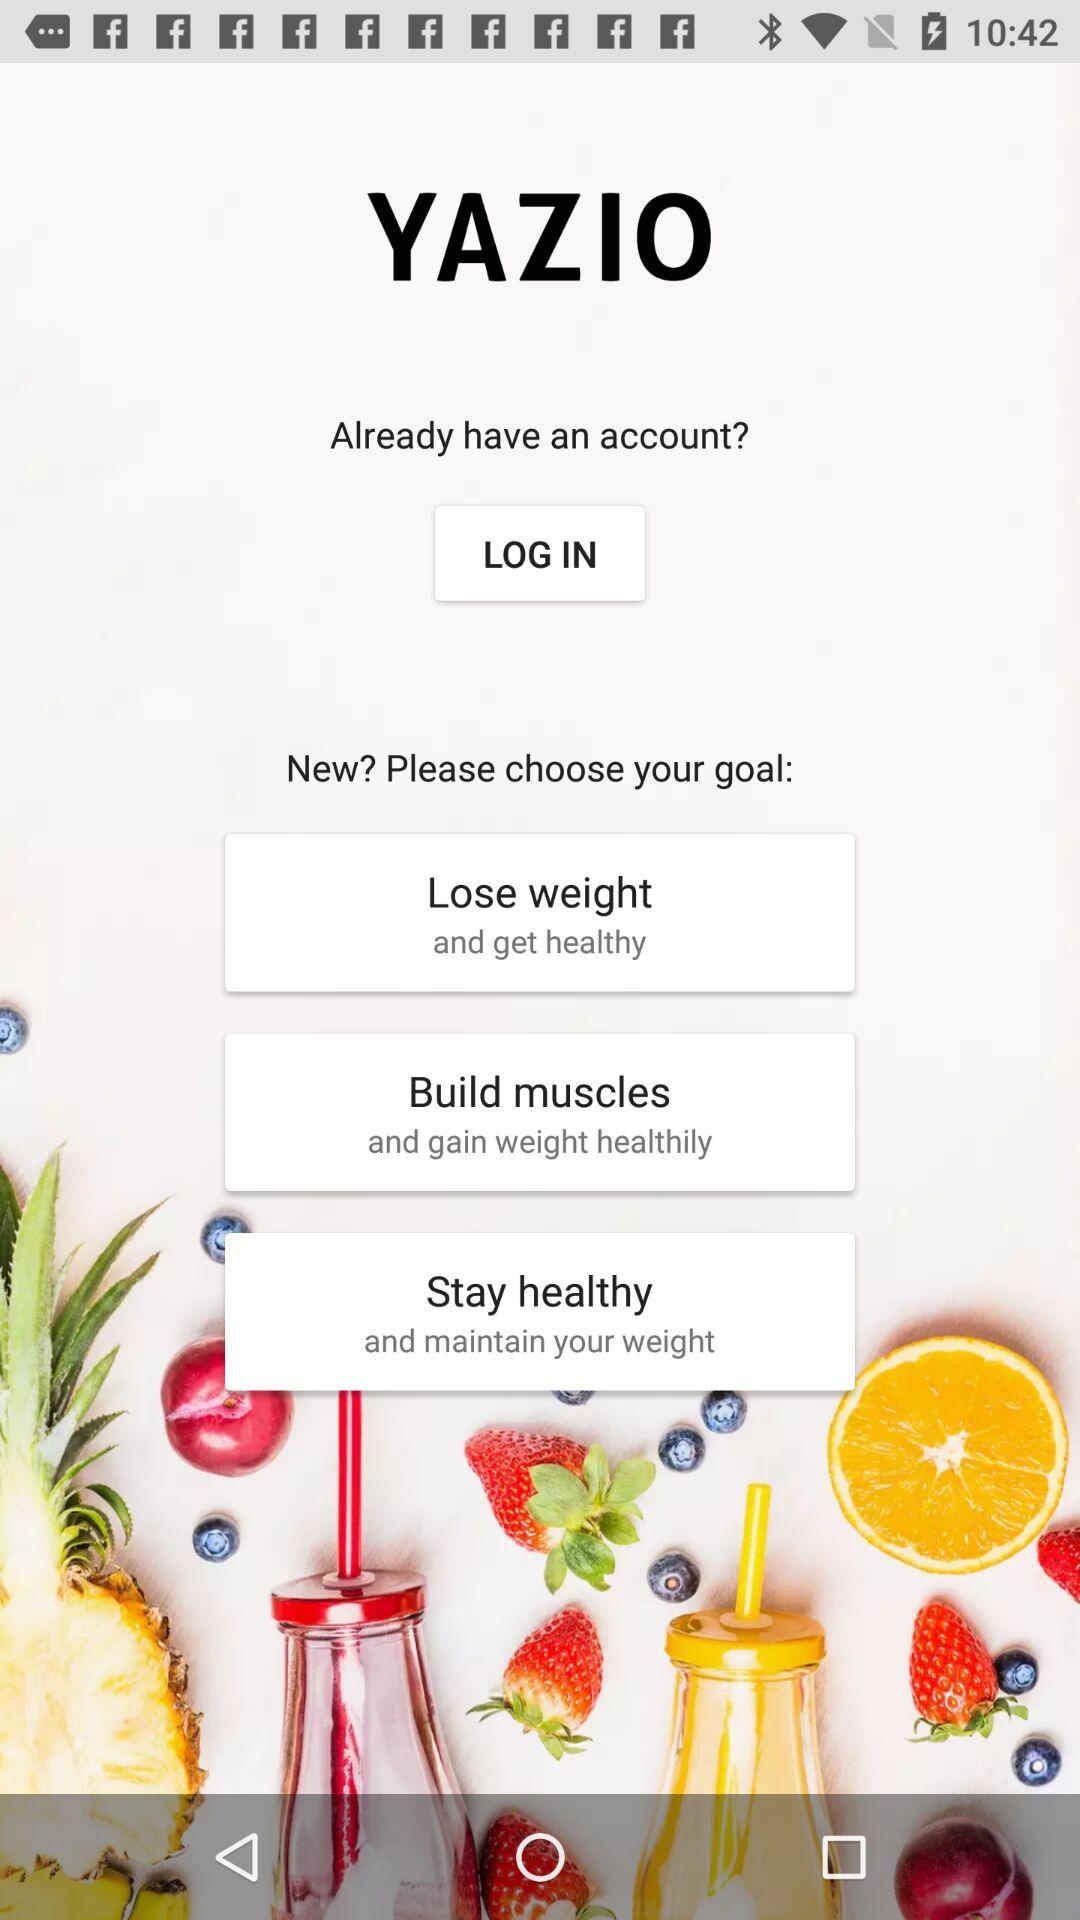What is the name of the application? The name of the application is "YAZIO". 